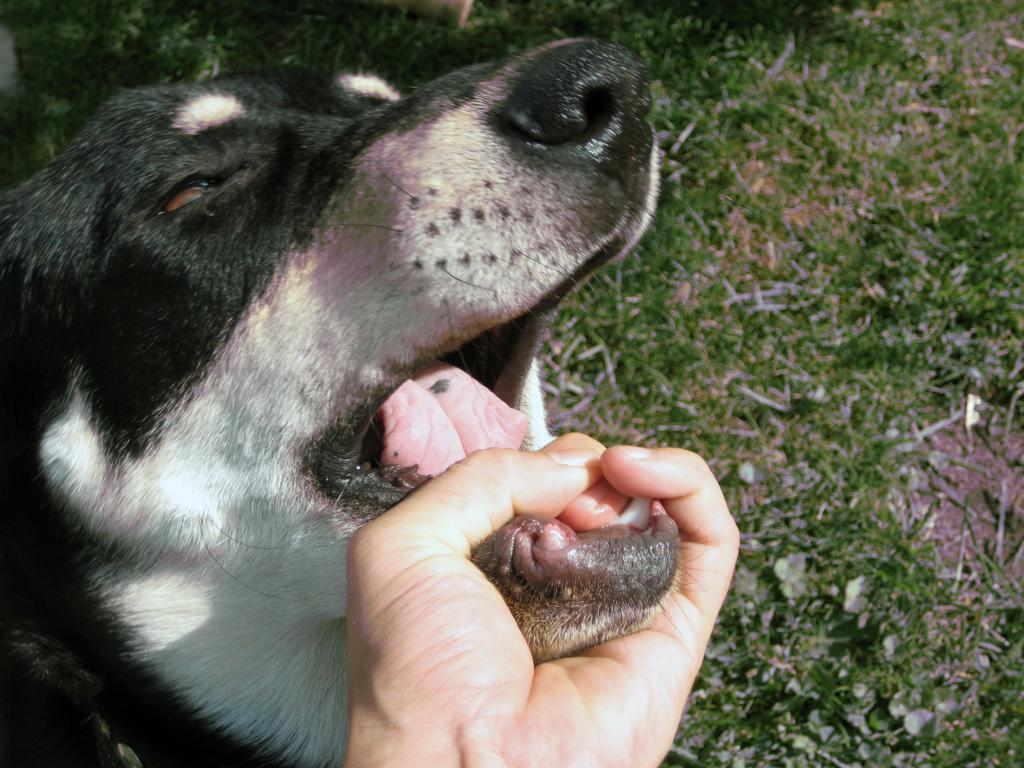What is the main subject of the image? The main subject of the image is a dog's face. What is the color scheme of the image? The image is in black and white. What is the person in the image doing with the dog's face? The person is holding the dog's mouth with their hand. What type of watch is the creature wearing in the image? There is no creature or watch present in the image; it features a dog's face and a person holding the dog's mouth. 